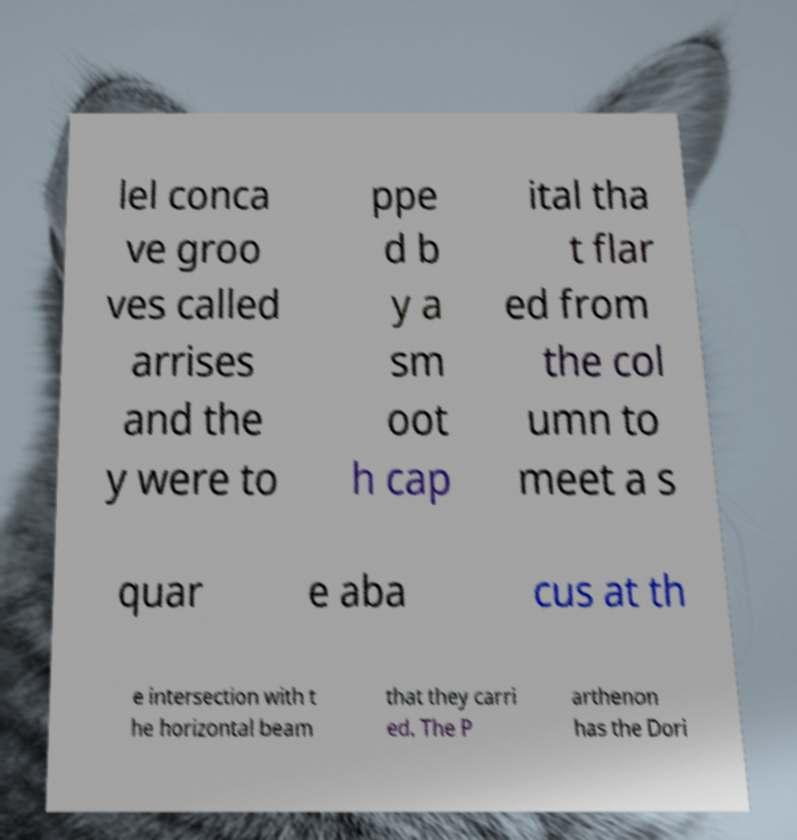I need the written content from this picture converted into text. Can you do that? lel conca ve groo ves called arrises and the y were to ppe d b y a sm oot h cap ital tha t flar ed from the col umn to meet a s quar e aba cus at th e intersection with t he horizontal beam that they carri ed. The P arthenon has the Dori 